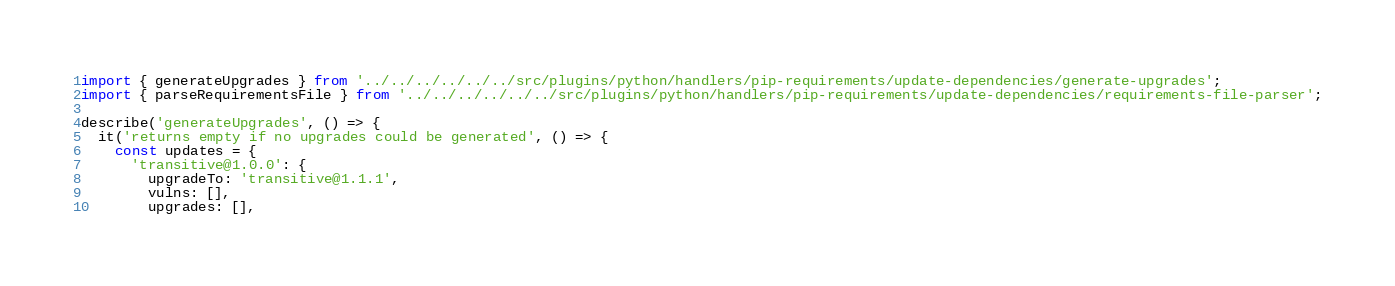Convert code to text. <code><loc_0><loc_0><loc_500><loc_500><_TypeScript_>import { generateUpgrades } from '../../../../../../src/plugins/python/handlers/pip-requirements/update-dependencies/generate-upgrades';
import { parseRequirementsFile } from '../../../../../../src/plugins/python/handlers/pip-requirements/update-dependencies/requirements-file-parser';

describe('generateUpgrades', () => {
  it('returns empty if no upgrades could be generated', () => {
    const updates = {
      'transitive@1.0.0': {
        upgradeTo: 'transitive@1.1.1',
        vulns: [],
        upgrades: [],</code> 